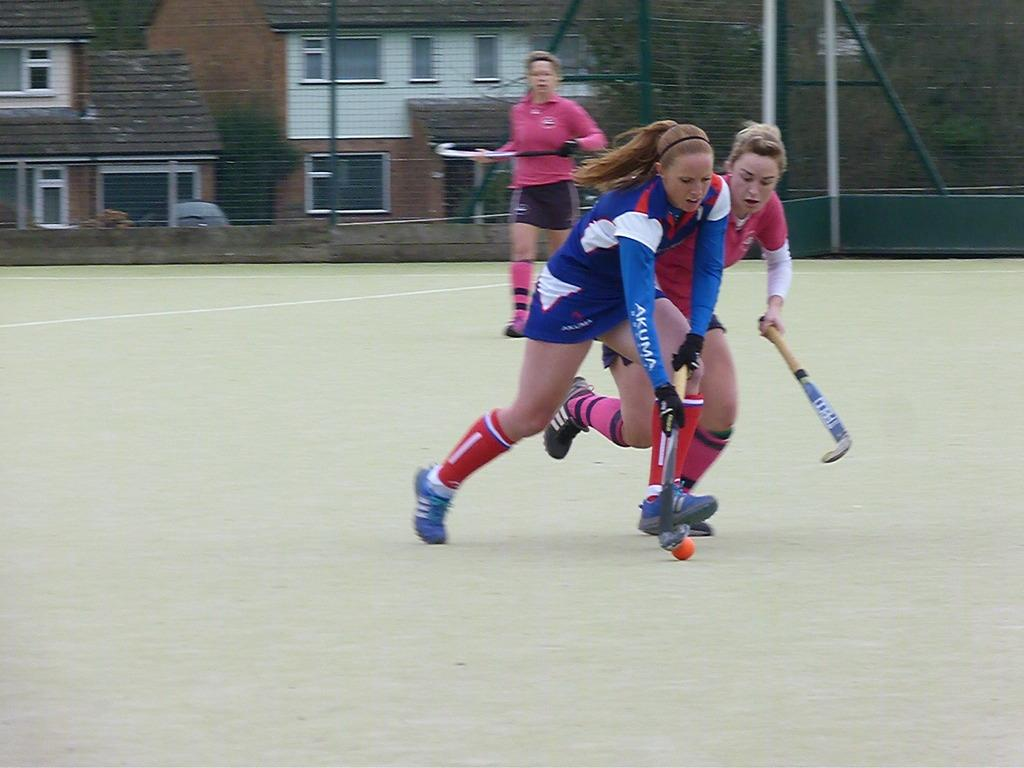What sport are the women playing in the image? The women are playing hockey in the image. What is surrounding the ground where the women are playing? There is a fencing made of MS around the ground. What can be seen behind the fencing? Behind the fencing, there is a building and trees visible. What type of flower is growing on the hockey field in the image? There are no flowers visible on the hockey field in the image. 